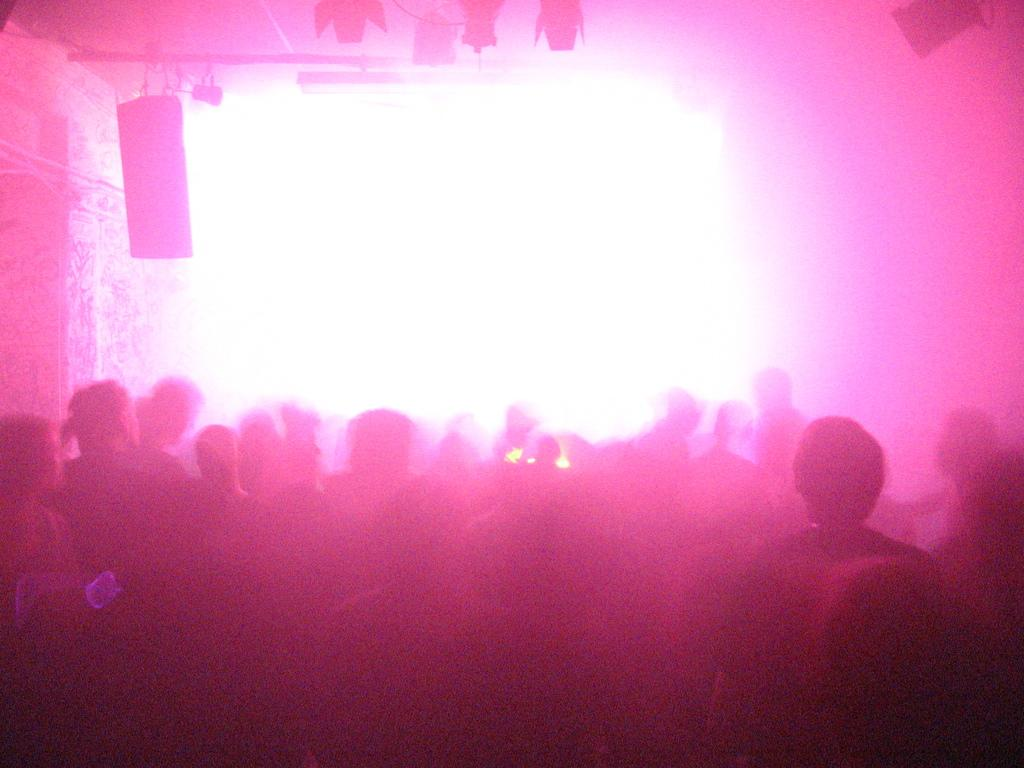What is present in the image? There are people in the image. Can you describe any objects or elements in the image besides the people? Yes, there are objects at the top of the image. What type of agreement is being discussed by the people in the image? There is no indication in the image of any discussion or agreement among the people. 